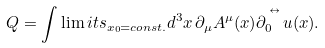<formula> <loc_0><loc_0><loc_500><loc_500>Q = \int \lim i t s _ { x _ { 0 } = c o n s t . } d ^ { 3 } x \, \partial _ { \mu } A ^ { \mu } ( x ) \partial ^ { \, ^ { ^ { \leftrightarrow } } } _ { 0 } u ( x ) .</formula> 